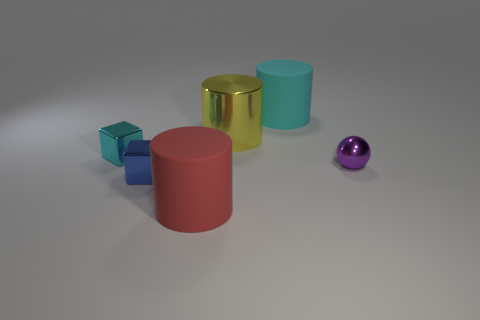Are there more cyan shiny things on the left side of the red rubber cylinder than small gray blocks?
Your answer should be very brief. Yes. What is the shape of the metallic thing that is both to the right of the red rubber thing and behind the purple shiny object?
Offer a very short reply. Cylinder. Do the red rubber thing and the purple thing have the same size?
Make the answer very short. No. What number of objects are behind the red cylinder?
Offer a terse response. 5. Is the number of tiny cyan shiny cubes that are in front of the small purple metal ball the same as the number of big cylinders in front of the yellow metallic cylinder?
Offer a very short reply. No. Does the large matte thing that is behind the yellow shiny cylinder have the same shape as the big yellow shiny thing?
Provide a short and direct response. Yes. Are there any other things that are made of the same material as the large red thing?
Offer a very short reply. Yes. Do the yellow thing and the cube behind the tiny shiny ball have the same size?
Offer a very short reply. No. What number of other objects are there of the same color as the small metal sphere?
Offer a very short reply. 0. There is a big metal cylinder; are there any large matte cylinders to the left of it?
Offer a terse response. Yes. 